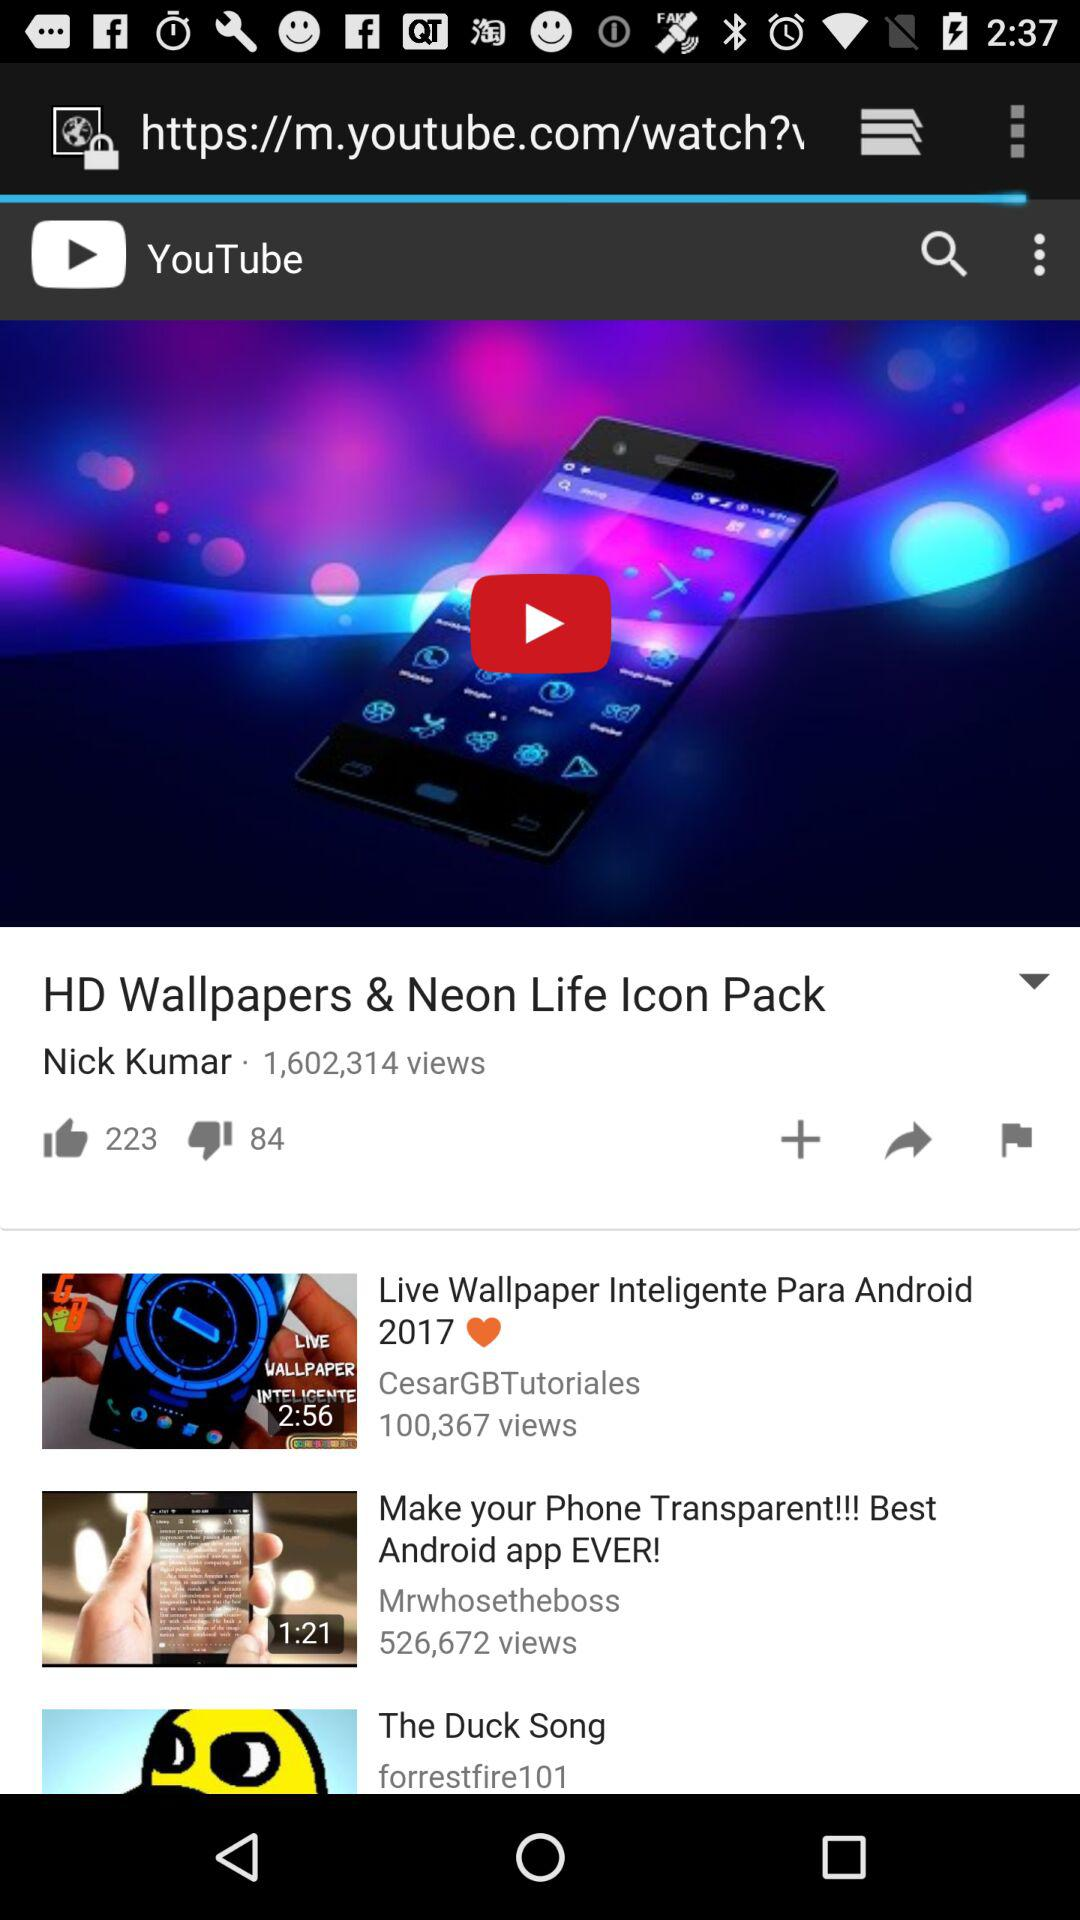What is the duration of the "Make your Phone Transparent!!!" video? The duration of the video is 1:21. 